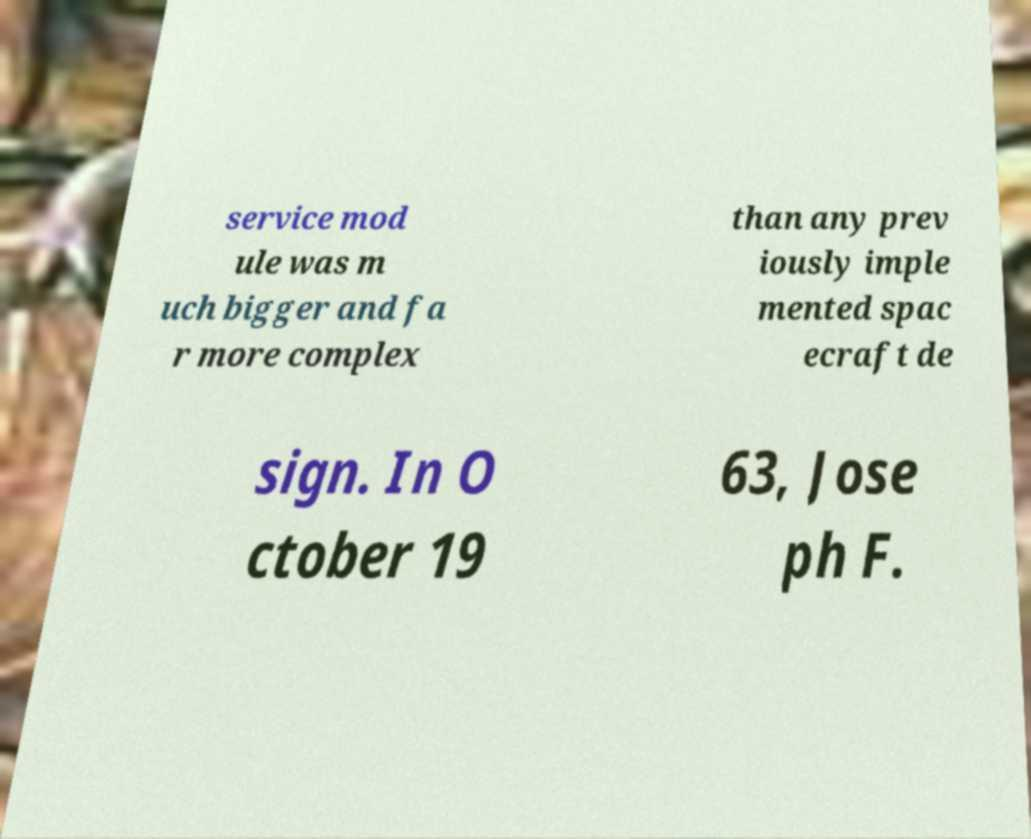There's text embedded in this image that I need extracted. Can you transcribe it verbatim? service mod ule was m uch bigger and fa r more complex than any prev iously imple mented spac ecraft de sign. In O ctober 19 63, Jose ph F. 